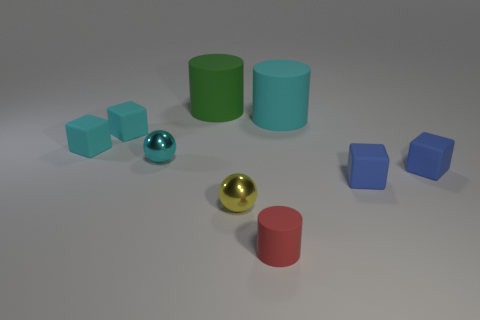Subtract all cyan cylinders. How many cylinders are left? 2 Add 1 rubber cylinders. How many objects exist? 10 Subtract 1 cylinders. How many cylinders are left? 2 Subtract all gray spheres. How many blue cubes are left? 2 Subtract all cubes. How many objects are left? 5 Subtract all cyan balls. How many balls are left? 1 Subtract all brown blocks. Subtract all brown balls. How many blocks are left? 4 Subtract all tiny gray rubber spheres. Subtract all cyan balls. How many objects are left? 8 Add 8 small yellow shiny spheres. How many small yellow shiny spheres are left? 9 Add 7 small cyan things. How many small cyan things exist? 10 